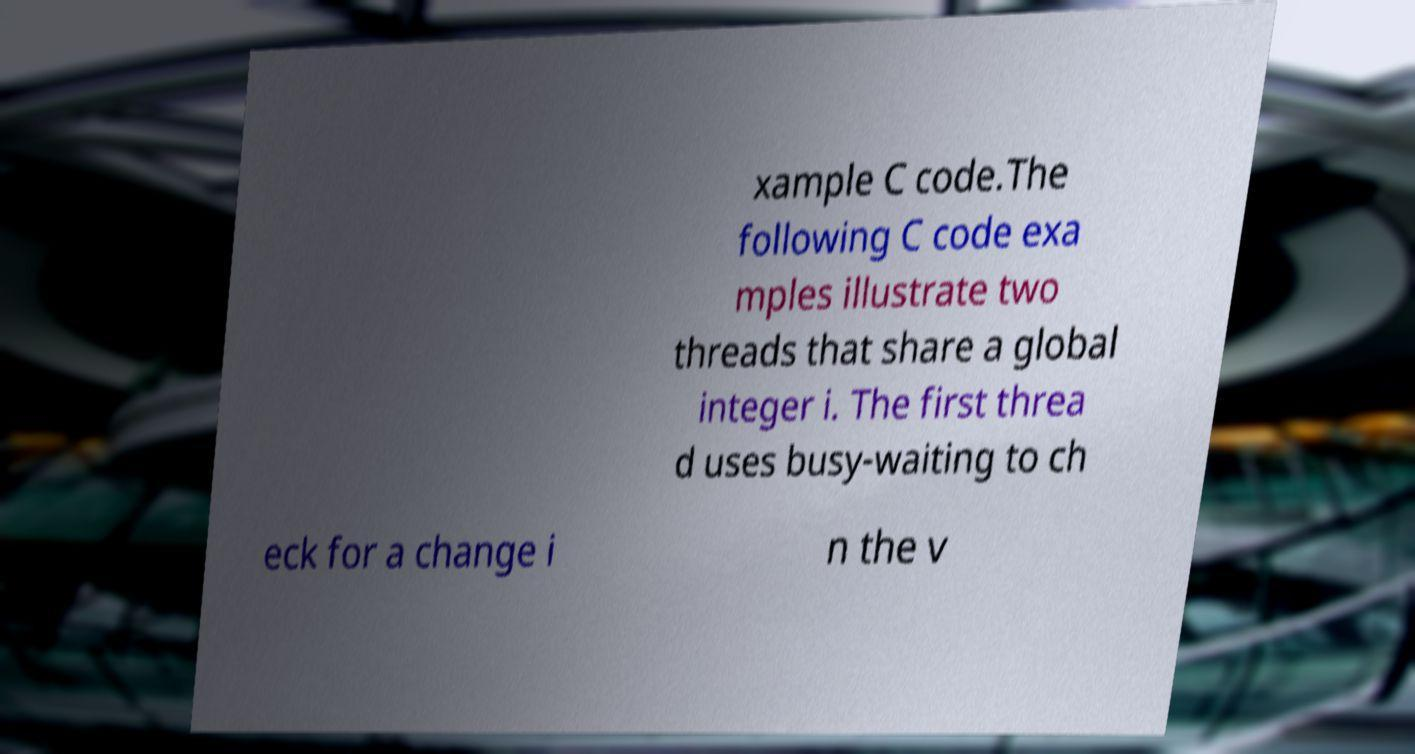Could you extract and type out the text from this image? xample C code.The following C code exa mples illustrate two threads that share a global integer i. The first threa d uses busy-waiting to ch eck for a change i n the v 